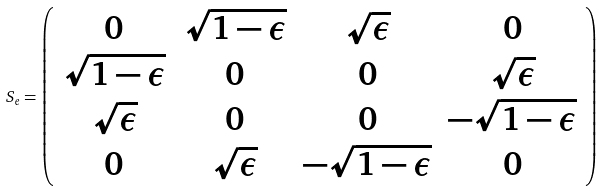<formula> <loc_0><loc_0><loc_500><loc_500>S _ { e } = \left ( \begin{array} { c c c c } 0 & \sqrt { 1 - \epsilon } & \sqrt { \epsilon } & 0 \\ \sqrt { 1 - \epsilon } & 0 & 0 & \sqrt { \epsilon } \\ \sqrt { \epsilon } & 0 & 0 & - \sqrt { 1 - \epsilon } \\ 0 & \sqrt { \epsilon } & - \sqrt { 1 - \epsilon } & 0 \\ \end{array} \right )</formula> 